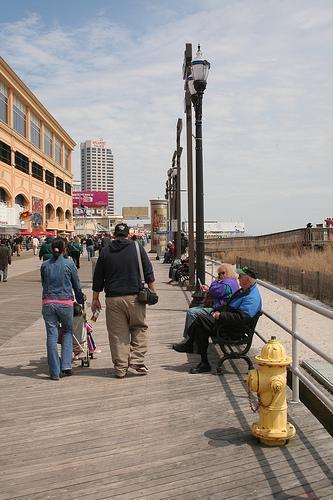How many people are pushing a stroller?
Give a very brief answer. 1. 